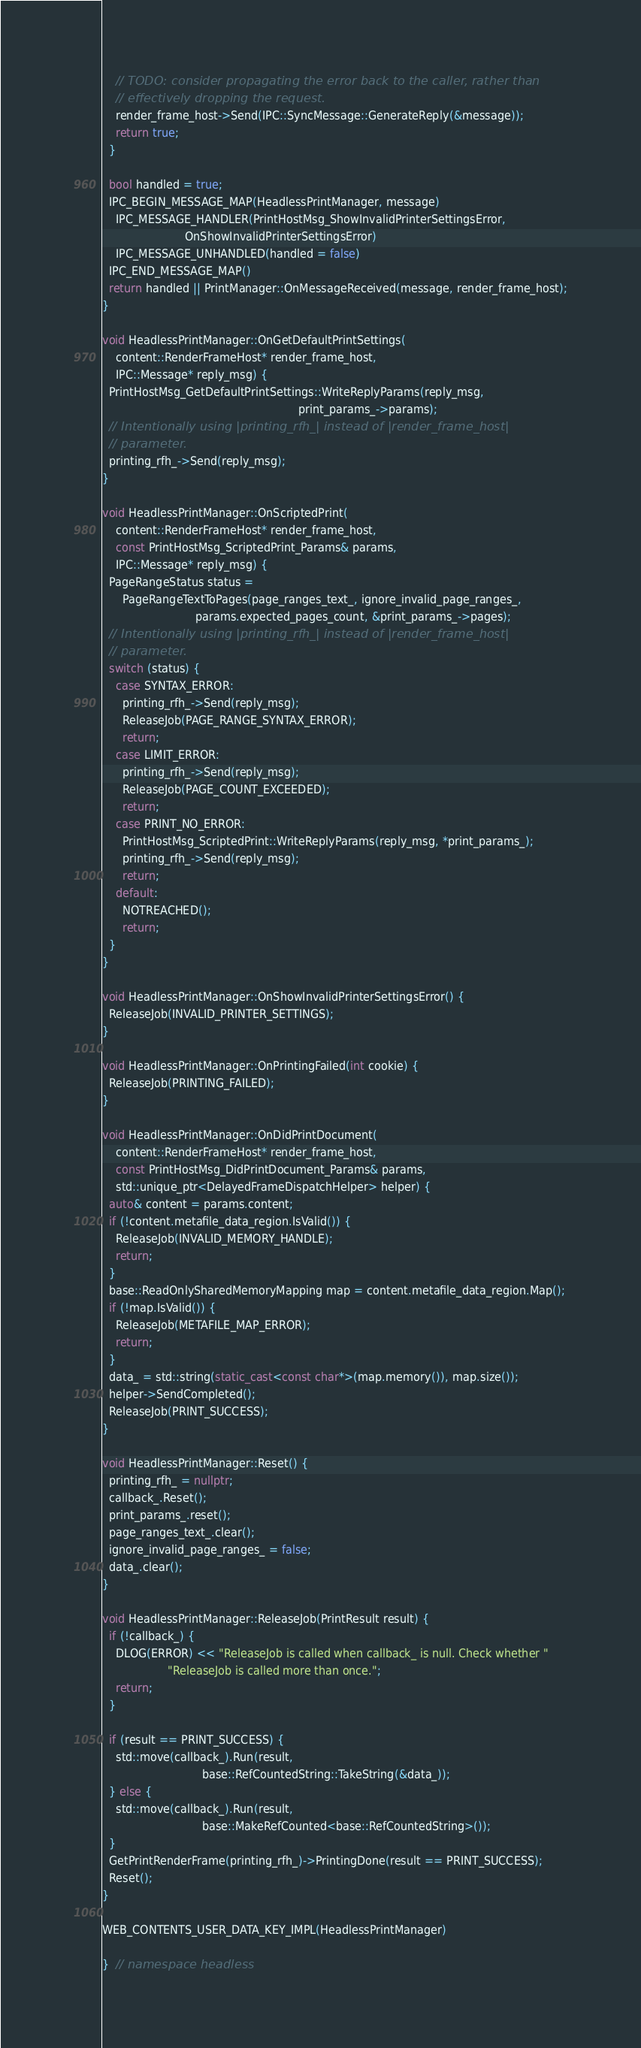Convert code to text. <code><loc_0><loc_0><loc_500><loc_500><_C++_>    // TODO: consider propagating the error back to the caller, rather than
    // effectively dropping the request.
    render_frame_host->Send(IPC::SyncMessage::GenerateReply(&message));
    return true;
  }

  bool handled = true;
  IPC_BEGIN_MESSAGE_MAP(HeadlessPrintManager, message)
    IPC_MESSAGE_HANDLER(PrintHostMsg_ShowInvalidPrinterSettingsError,
                        OnShowInvalidPrinterSettingsError)
    IPC_MESSAGE_UNHANDLED(handled = false)
  IPC_END_MESSAGE_MAP()
  return handled || PrintManager::OnMessageReceived(message, render_frame_host);
}

void HeadlessPrintManager::OnGetDefaultPrintSettings(
    content::RenderFrameHost* render_frame_host,
    IPC::Message* reply_msg) {
  PrintHostMsg_GetDefaultPrintSettings::WriteReplyParams(reply_msg,
                                                         print_params_->params);
  // Intentionally using |printing_rfh_| instead of |render_frame_host|
  // parameter.
  printing_rfh_->Send(reply_msg);
}

void HeadlessPrintManager::OnScriptedPrint(
    content::RenderFrameHost* render_frame_host,
    const PrintHostMsg_ScriptedPrint_Params& params,
    IPC::Message* reply_msg) {
  PageRangeStatus status =
      PageRangeTextToPages(page_ranges_text_, ignore_invalid_page_ranges_,
                           params.expected_pages_count, &print_params_->pages);
  // Intentionally using |printing_rfh_| instead of |render_frame_host|
  // parameter.
  switch (status) {
    case SYNTAX_ERROR:
      printing_rfh_->Send(reply_msg);
      ReleaseJob(PAGE_RANGE_SYNTAX_ERROR);
      return;
    case LIMIT_ERROR:
      printing_rfh_->Send(reply_msg);
      ReleaseJob(PAGE_COUNT_EXCEEDED);
      return;
    case PRINT_NO_ERROR:
      PrintHostMsg_ScriptedPrint::WriteReplyParams(reply_msg, *print_params_);
      printing_rfh_->Send(reply_msg);
      return;
    default:
      NOTREACHED();
      return;
  }
}

void HeadlessPrintManager::OnShowInvalidPrinterSettingsError() {
  ReleaseJob(INVALID_PRINTER_SETTINGS);
}

void HeadlessPrintManager::OnPrintingFailed(int cookie) {
  ReleaseJob(PRINTING_FAILED);
}

void HeadlessPrintManager::OnDidPrintDocument(
    content::RenderFrameHost* render_frame_host,
    const PrintHostMsg_DidPrintDocument_Params& params,
    std::unique_ptr<DelayedFrameDispatchHelper> helper) {
  auto& content = params.content;
  if (!content.metafile_data_region.IsValid()) {
    ReleaseJob(INVALID_MEMORY_HANDLE);
    return;
  }
  base::ReadOnlySharedMemoryMapping map = content.metafile_data_region.Map();
  if (!map.IsValid()) {
    ReleaseJob(METAFILE_MAP_ERROR);
    return;
  }
  data_ = std::string(static_cast<const char*>(map.memory()), map.size());
  helper->SendCompleted();
  ReleaseJob(PRINT_SUCCESS);
}

void HeadlessPrintManager::Reset() {
  printing_rfh_ = nullptr;
  callback_.Reset();
  print_params_.reset();
  page_ranges_text_.clear();
  ignore_invalid_page_ranges_ = false;
  data_.clear();
}

void HeadlessPrintManager::ReleaseJob(PrintResult result) {
  if (!callback_) {
    DLOG(ERROR) << "ReleaseJob is called when callback_ is null. Check whether "
                   "ReleaseJob is called more than once.";
    return;
  }

  if (result == PRINT_SUCCESS) {
    std::move(callback_).Run(result,
                             base::RefCountedString::TakeString(&data_));
  } else {
    std::move(callback_).Run(result,
                             base::MakeRefCounted<base::RefCountedString>());
  }
  GetPrintRenderFrame(printing_rfh_)->PrintingDone(result == PRINT_SUCCESS);
  Reset();
}

WEB_CONTENTS_USER_DATA_KEY_IMPL(HeadlessPrintManager)

}  // namespace headless
</code> 